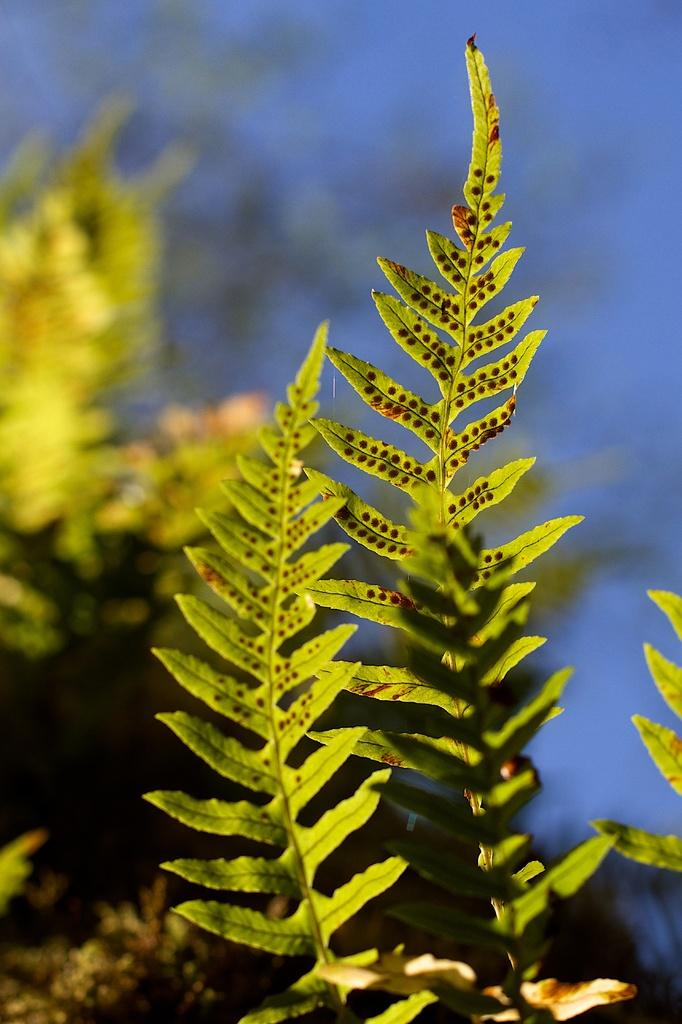What is present in the image? There are plants in the image. Can you describe the background of the image? The background of the image is blurred. How many jellyfish can be seen swimming in the image? There are no jellyfish present in the image; it features plants and a blurred background. What type of lettuce is being used as a garnish in the image? There is no lettuce or any food item present in the image; it only contains plants and a blurred background. 